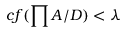<formula> <loc_0><loc_0><loc_500><loc_500>c f ( \prod A / D ) < \lambda</formula> 